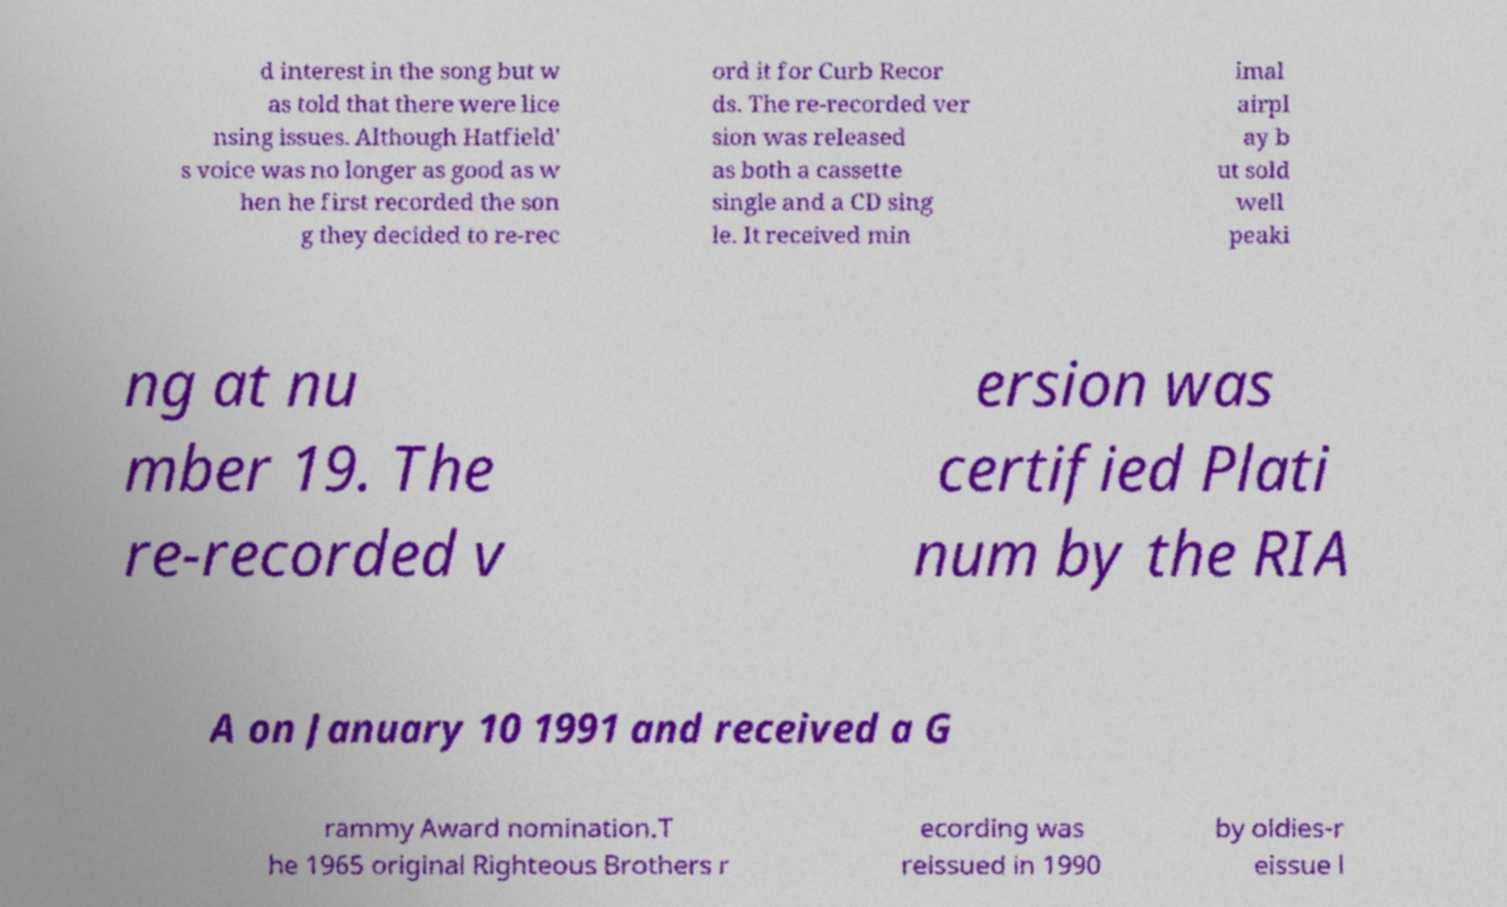Please identify and transcribe the text found in this image. d interest in the song but w as told that there were lice nsing issues. Although Hatfield' s voice was no longer as good as w hen he first recorded the son g they decided to re-rec ord it for Curb Recor ds. The re-recorded ver sion was released as both a cassette single and a CD sing le. It received min imal airpl ay b ut sold well peaki ng at nu mber 19. The re-recorded v ersion was certified Plati num by the RIA A on January 10 1991 and received a G rammy Award nomination.T he 1965 original Righteous Brothers r ecording was reissued in 1990 by oldies-r eissue l 